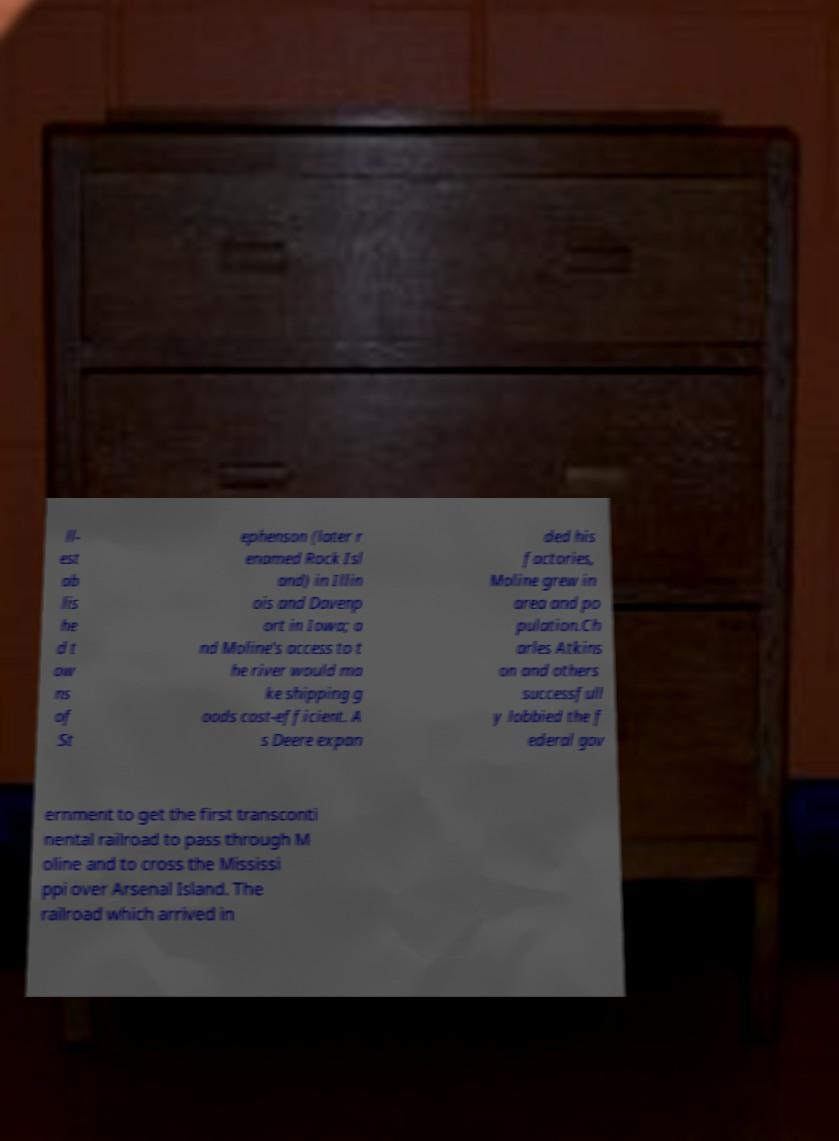There's text embedded in this image that I need extracted. Can you transcribe it verbatim? ll- est ab lis he d t ow ns of St ephenson (later r enamed Rock Isl and) in Illin ois and Davenp ort in Iowa; a nd Moline's access to t he river would ma ke shipping g oods cost-efficient. A s Deere expan ded his factories, Moline grew in area and po pulation.Ch arles Atkins on and others successfull y lobbied the f ederal gov ernment to get the first transconti nental railroad to pass through M oline and to cross the Mississi ppi over Arsenal Island. The railroad which arrived in 